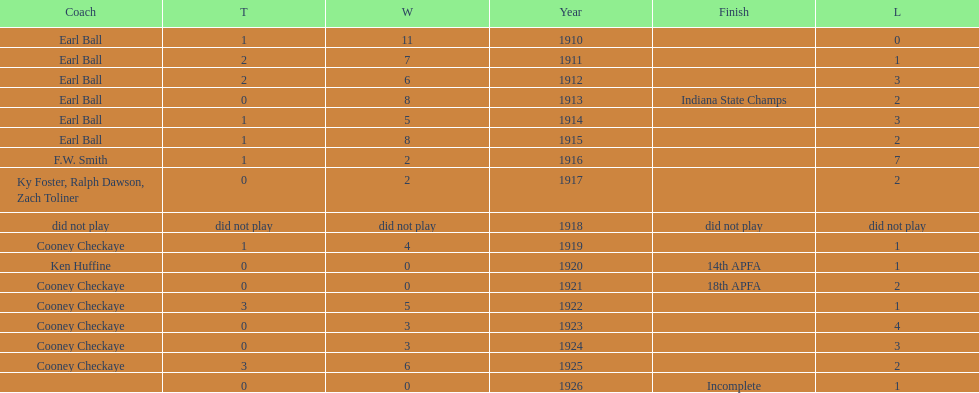How many years did earl ball coach the muncie flyers? 6. 